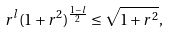Convert formula to latex. <formula><loc_0><loc_0><loc_500><loc_500>r ^ { l } ( 1 + r ^ { 2 } ) ^ { { \frac { 1 - l } { 2 } } } \leq \sqrt { 1 + r ^ { 2 } } ,</formula> 